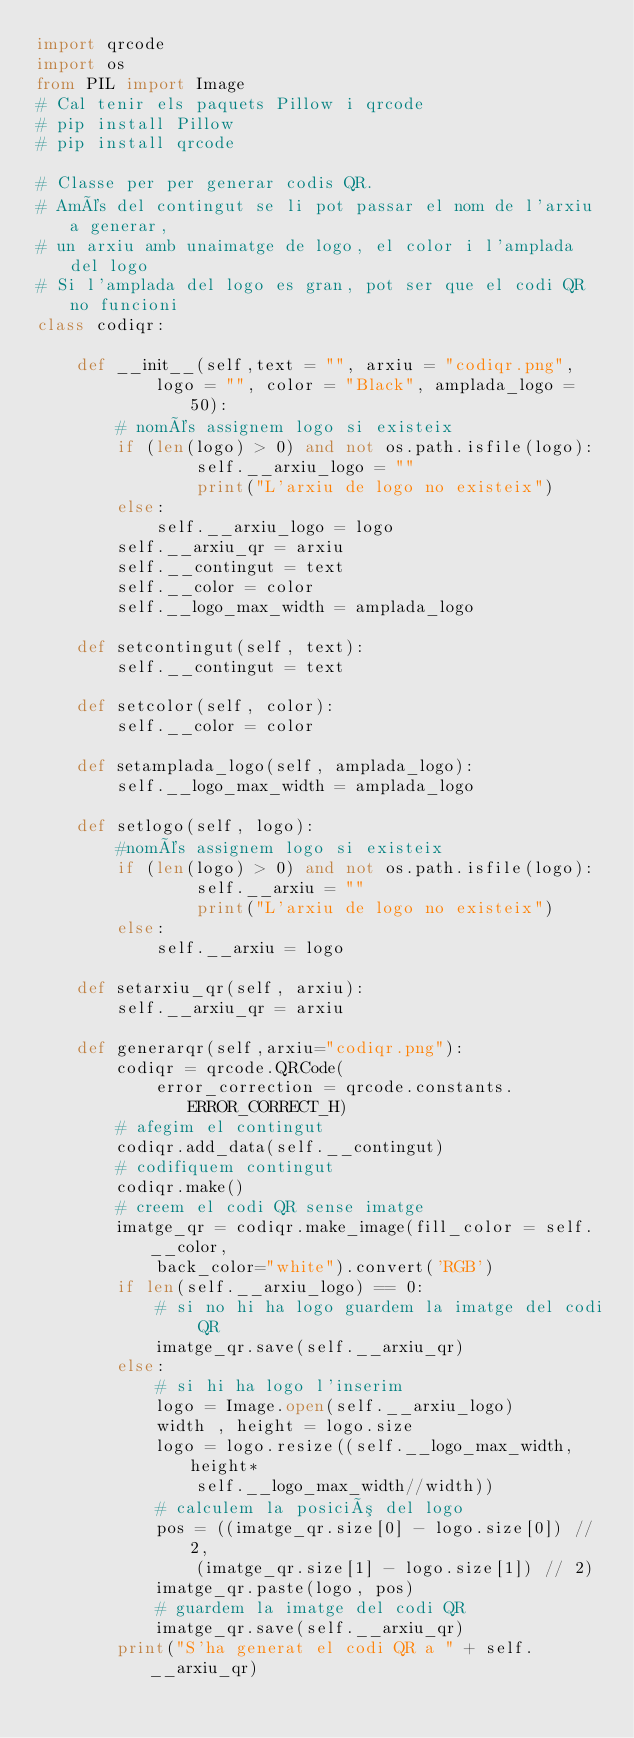Convert code to text. <code><loc_0><loc_0><loc_500><loc_500><_Python_>import qrcode
import os
from PIL import Image
# Cal tenir els paquets Pillow i qrcode
# pip install Pillow
# pip install qrcode

# Classe per per generar codis QR. 
# Amés del contingut se li pot passar el nom de l'arxiu a generar,
# un arxiu amb unaimatge de logo, el color i l'amplada del logo
# Si l'amplada del logo es gran, pot ser que el codi QR no funcioni 
class codiqr:

    def __init__(self,text = "", arxiu = "codiqr.png", 
            logo = "", color = "Black", amplada_logo = 50):
        # només assignem logo si existeix
        if (len(logo) > 0) and not os.path.isfile(logo):
                self.__arxiu_logo = ""
                print("L'arxiu de logo no existeix")
        else:
            self.__arxiu_logo = logo
        self.__arxiu_qr = arxiu
        self.__contingut = text
        self.__color = color
        self.__logo_max_width = amplada_logo

    def setcontingut(self, text):
        self.__contingut = text

    def setcolor(self, color):
        self.__color = color

    def setamplada_logo(self, amplada_logo):
        self.__logo_max_width = amplada_logo

    def setlogo(self, logo):
        #només assignem logo si existeix
        if (len(logo) > 0) and not os.path.isfile(logo):
                self.__arxiu = ""
                print("L'arxiu de logo no existeix")
        else:
            self.__arxiu = logo

    def setarxiu_qr(self, arxiu):
        self.__arxiu_qr = arxiu

    def generarqr(self,arxiu="codiqr.png"):
        codiqr = qrcode.QRCode(
            error_correction = qrcode.constants.ERROR_CORRECT_H)
        # afegim el contingut
        codiqr.add_data(self.__contingut) 
        # codifiquem contingut
        codiqr.make()
        # creem el codi QR sense imatge
        imatge_qr = codiqr.make_image(fill_color = self.__color, 
            back_color="white").convert('RGB')
        if len(self.__arxiu_logo) == 0:
            # si no hi ha logo guardem la imatge del codi QR
            imatge_qr.save(self.__arxiu_qr)
        else:
            # si hi ha logo l'inserim
            logo = Image.open(self.__arxiu_logo)
            width , height = logo.size
            logo = logo.resize((self.__logo_max_width,height*
                self.__logo_max_width//width))
            # calculem la posició del logo
            pos = ((imatge_qr.size[0] - logo.size[0]) // 2,
                (imatge_qr.size[1] - logo.size[1]) // 2)
            imatge_qr.paste(logo, pos)            
            # guardem la imatge del codi QR
            imatge_qr.save(self.__arxiu_qr)
        print("S'ha generat el codi QR a " + self.__arxiu_qr)            
        </code> 